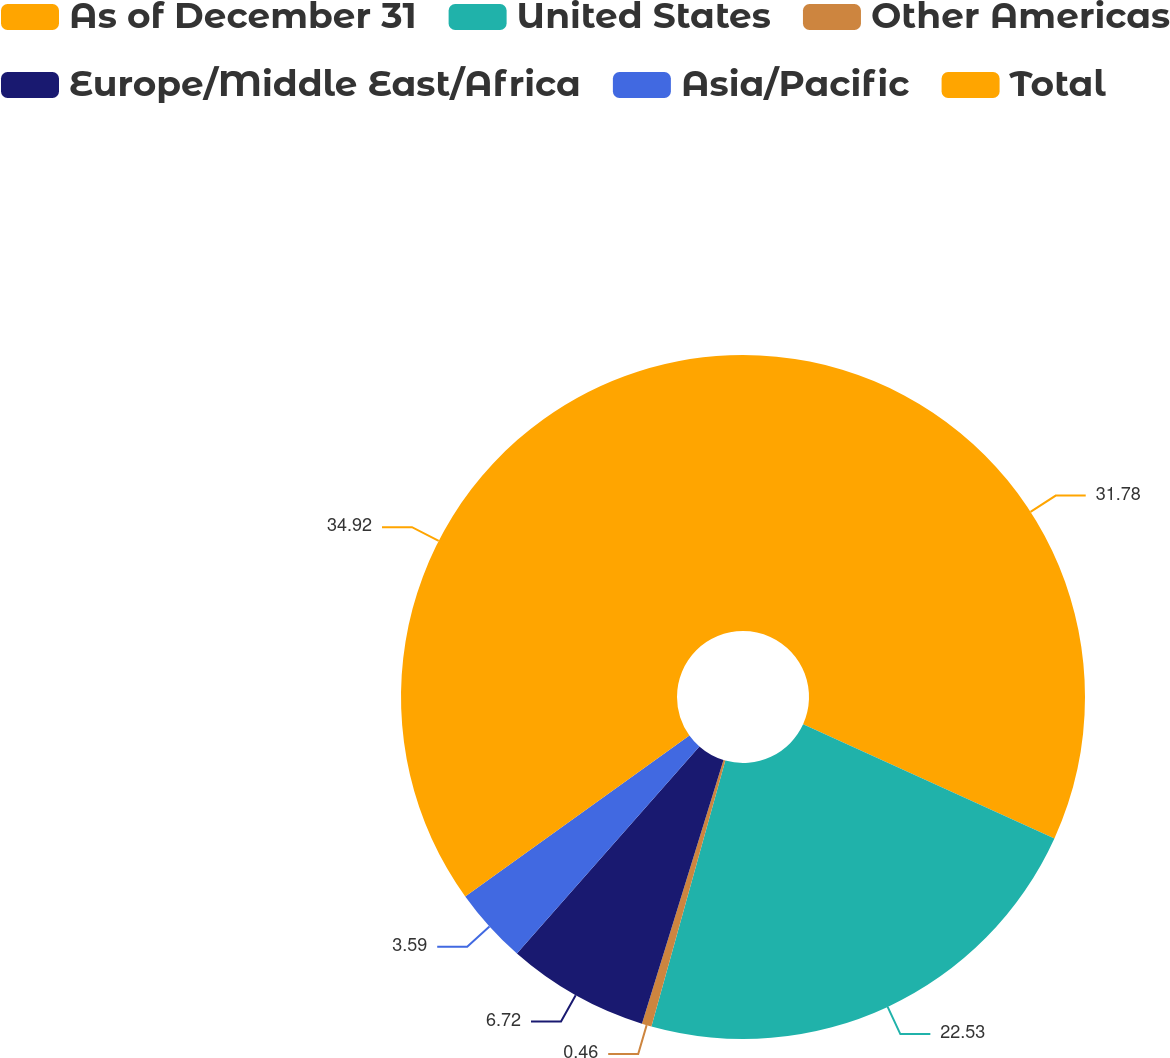Convert chart. <chart><loc_0><loc_0><loc_500><loc_500><pie_chart><fcel>As of December 31<fcel>United States<fcel>Other Americas<fcel>Europe/Middle East/Africa<fcel>Asia/Pacific<fcel>Total<nl><fcel>31.78%<fcel>22.53%<fcel>0.46%<fcel>6.72%<fcel>3.59%<fcel>34.91%<nl></chart> 